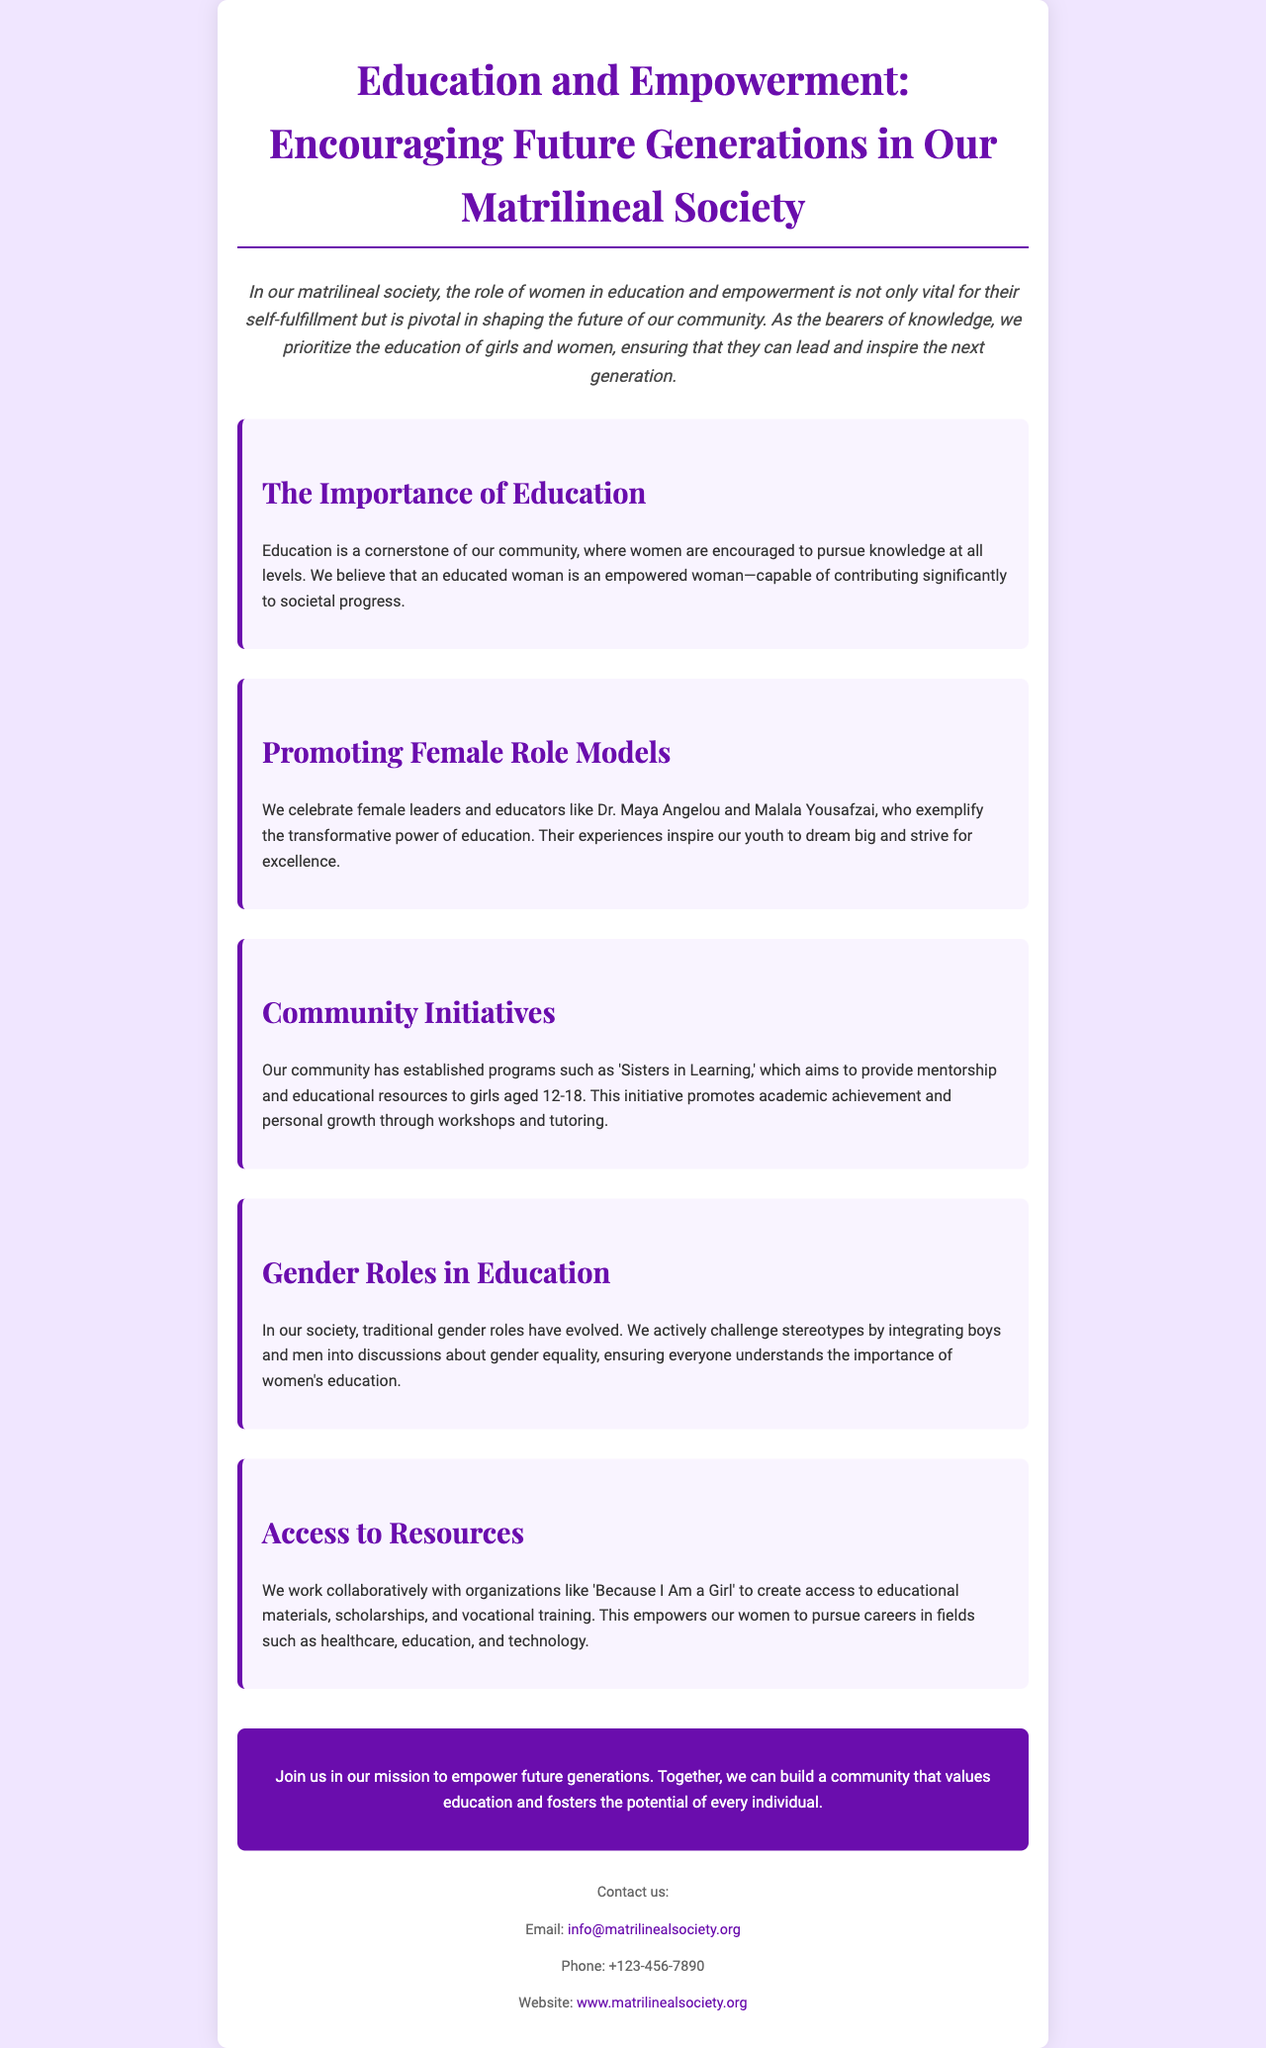What is the title of the brochure? The title is clearly stated at the top of the document.
Answer: Education and Empowerment: Encouraging Future Generations in Our Matrilineal Society How does the brochure describe the role of women in education? The introduction highlights the importance of women's roles in education and empowerment.
Answer: Vital for their self-fulfillment What is the name of the program mentioned in the community initiatives? This is specified in the section on community initiatives.
Answer: Sisters in Learning Who are two female leaders celebrated in the brochure? Mentioned in the section on promoting female role models.
Answer: Dr. Maya Angelou and Malala Yousafzai Which slogan does the brochure use to encourage community involvement? The call to action at the end summarizes this.
Answer: Join us in our mission to empower future generations What age group does the 'Sisters in Learning' program target? This information is found in the section about community initiatives.
Answer: Aged 12-18 What is one field that women are encouraged to pursue through training? Mentioned in the section about access to resources.
Answer: Healthcare What type of societal change does the brochure emphasize? Highlighted in the section on gender roles in education.
Answer: Evolving traditional gender roles 